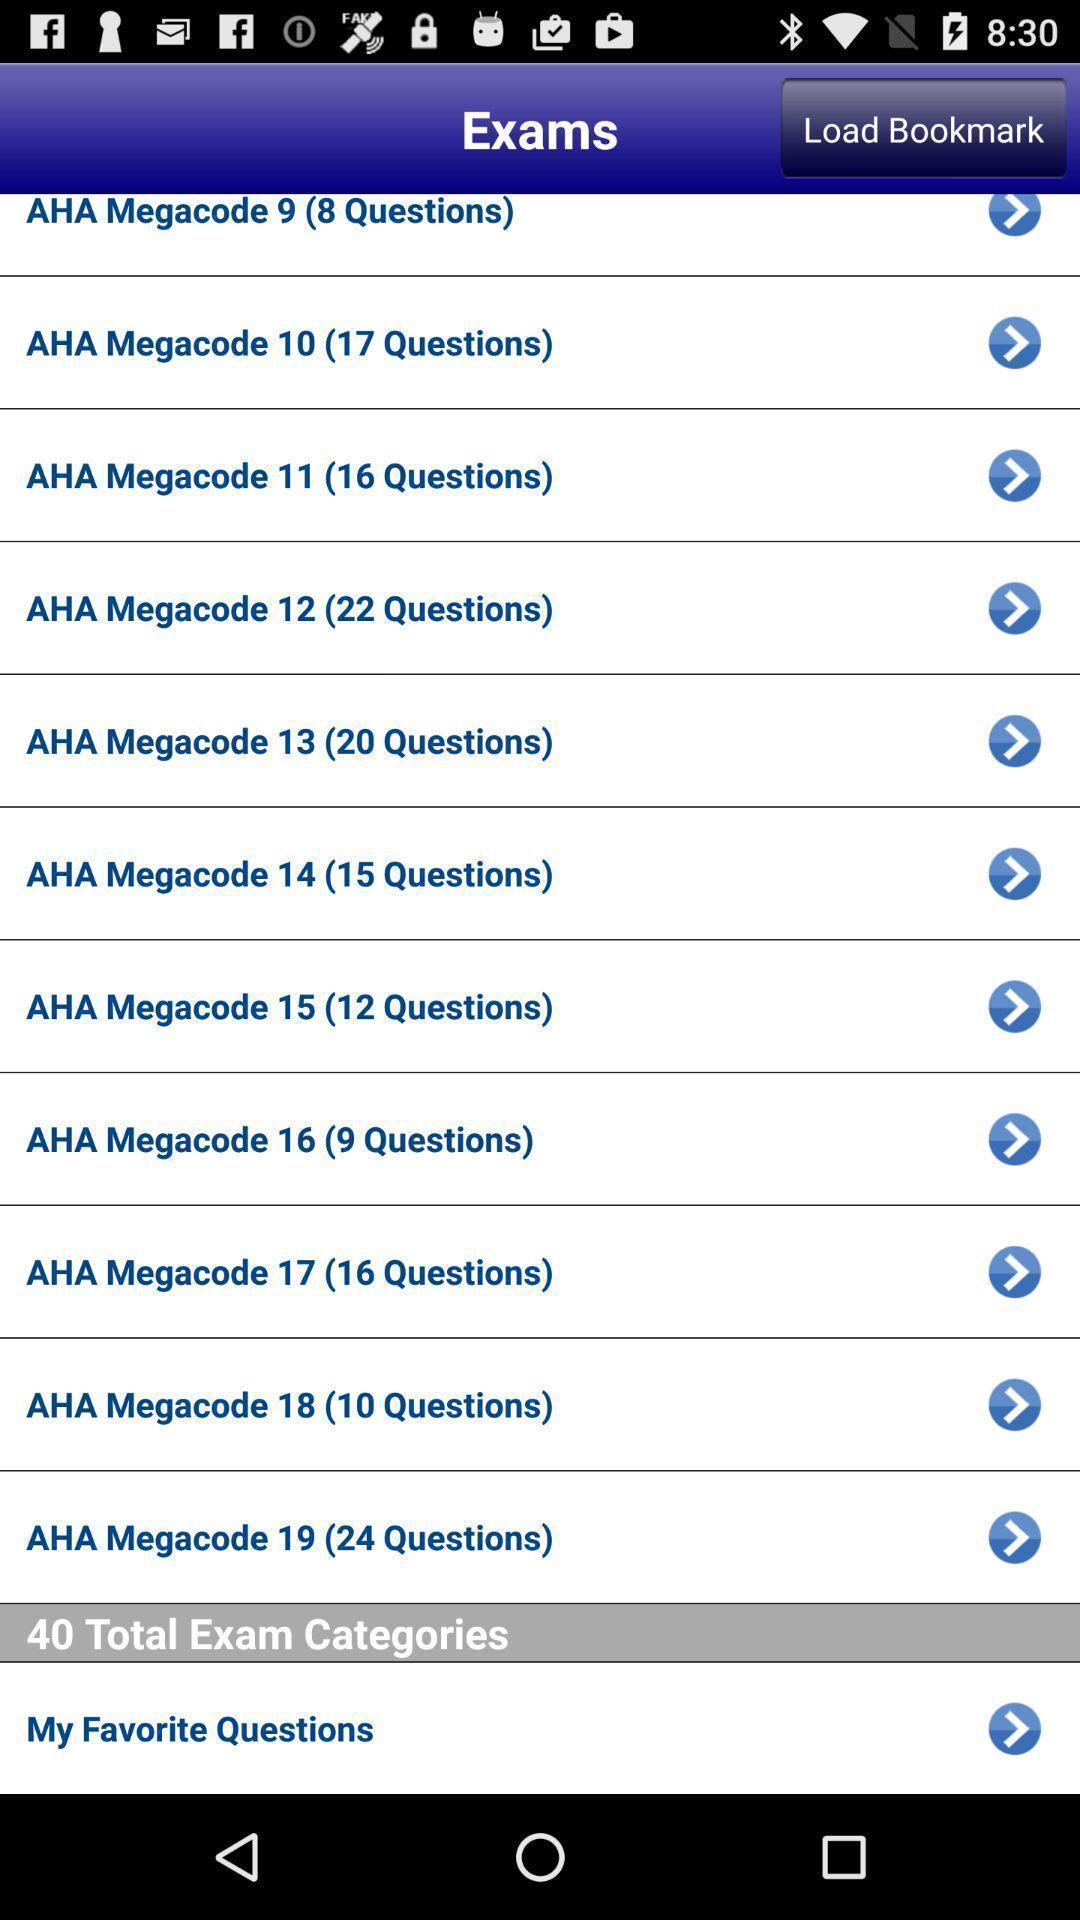Explain what's happening in this screen capture. Page showing list of exams. 